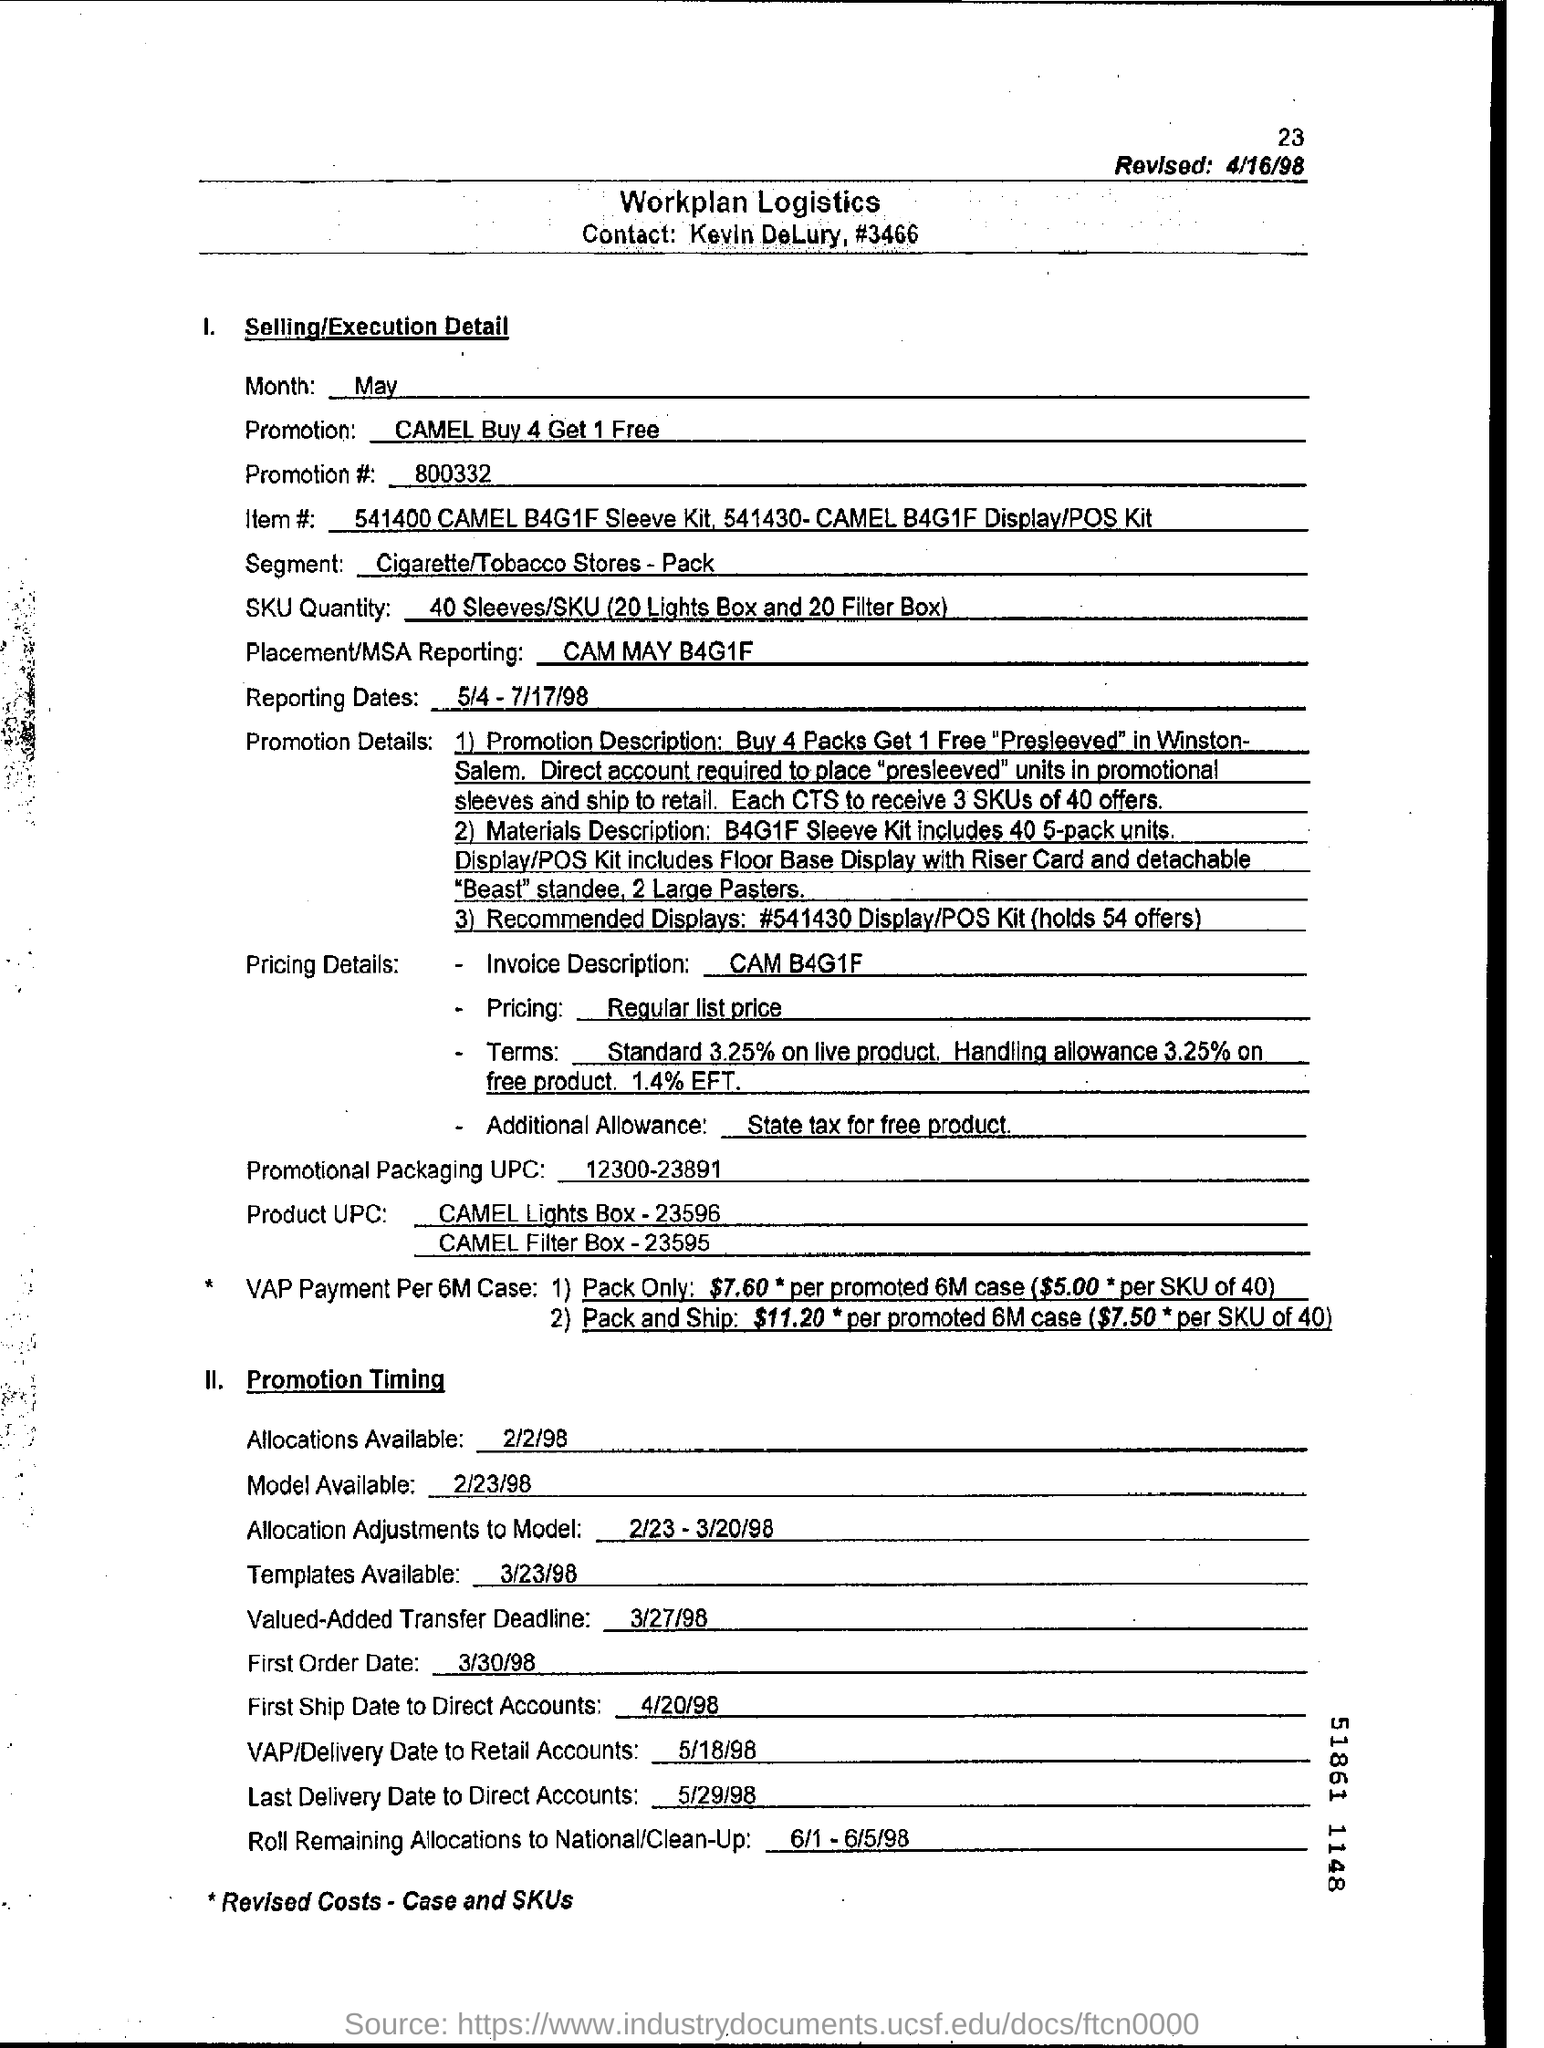What are the pricing details mentioned in the document? The pricing details in the document include different types of discounts such as an invoice description discount, an additional allowance, and a term discount for live product and EFT payment. It specifies the standard terms and additional state tax allowances for free products. 